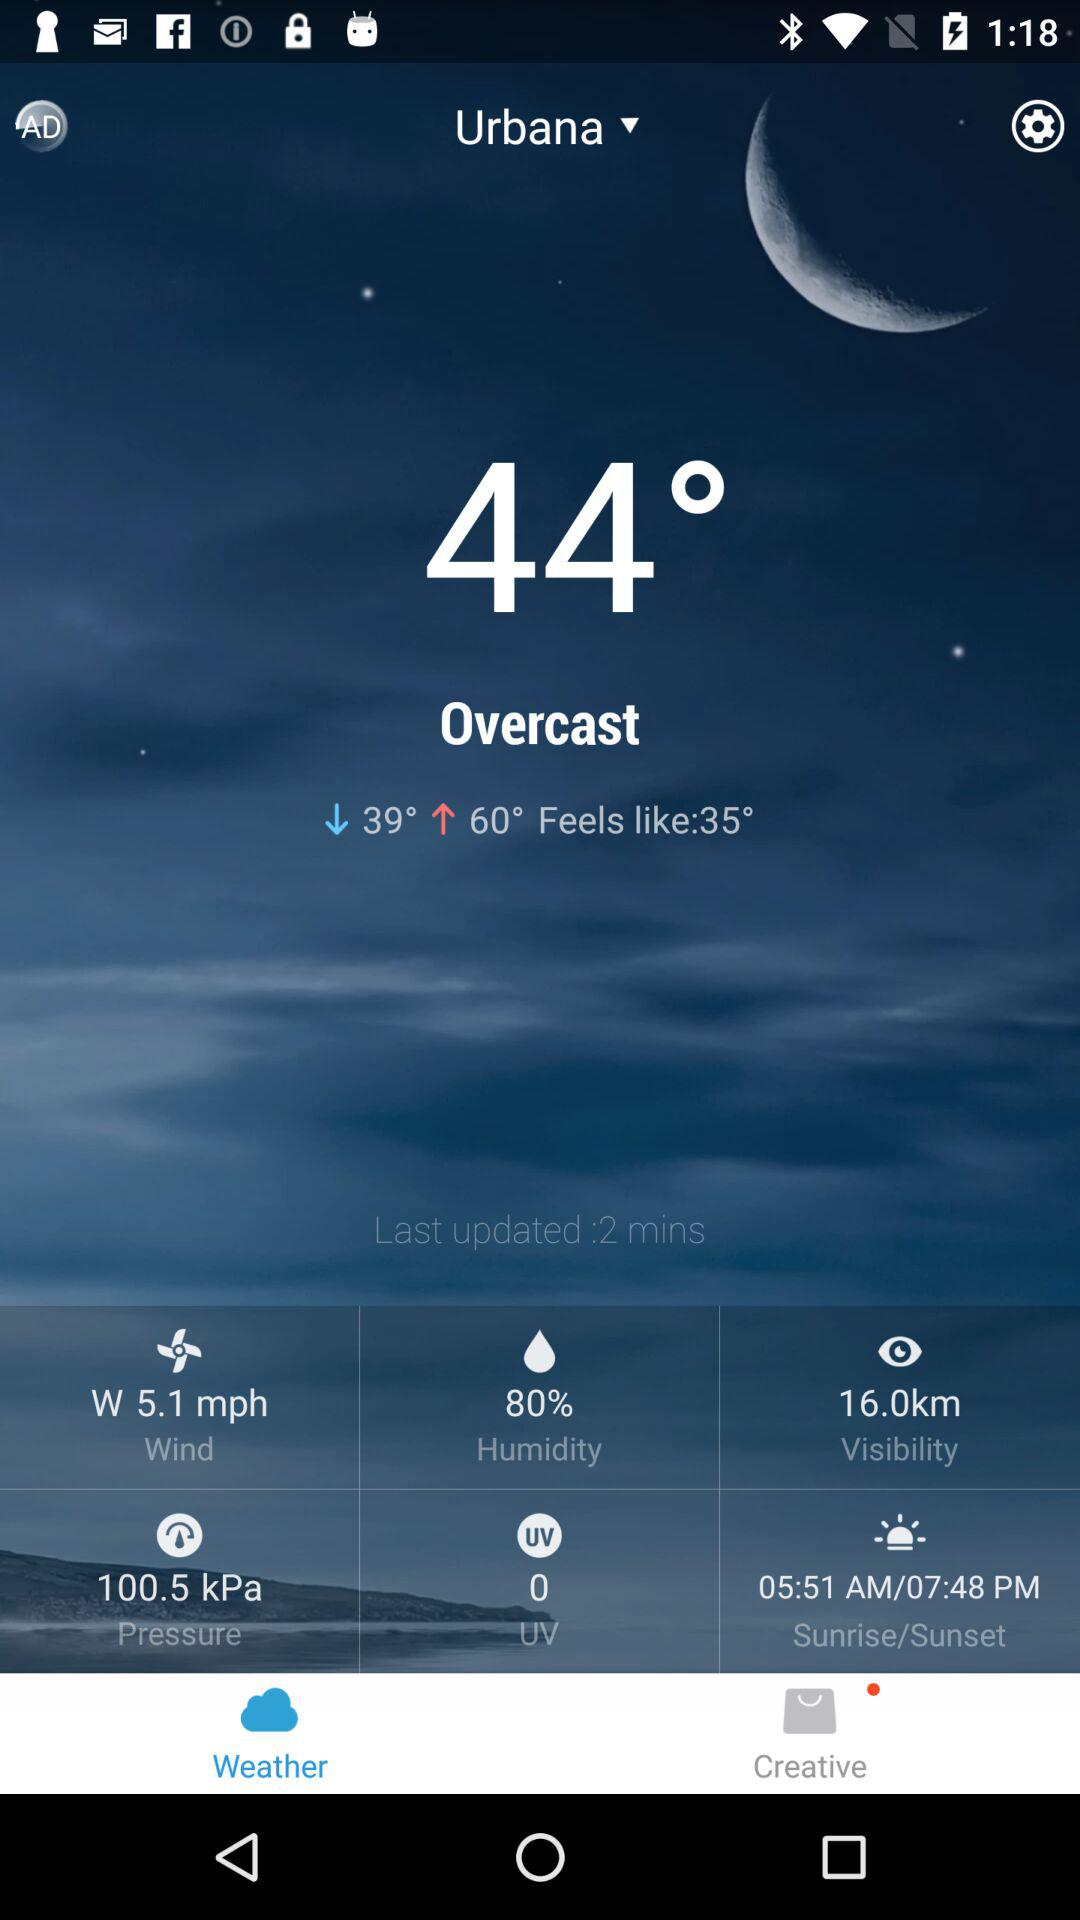What is the wind speed in the current weather report?
Answer the question using a single word or phrase. 5.1 mph 